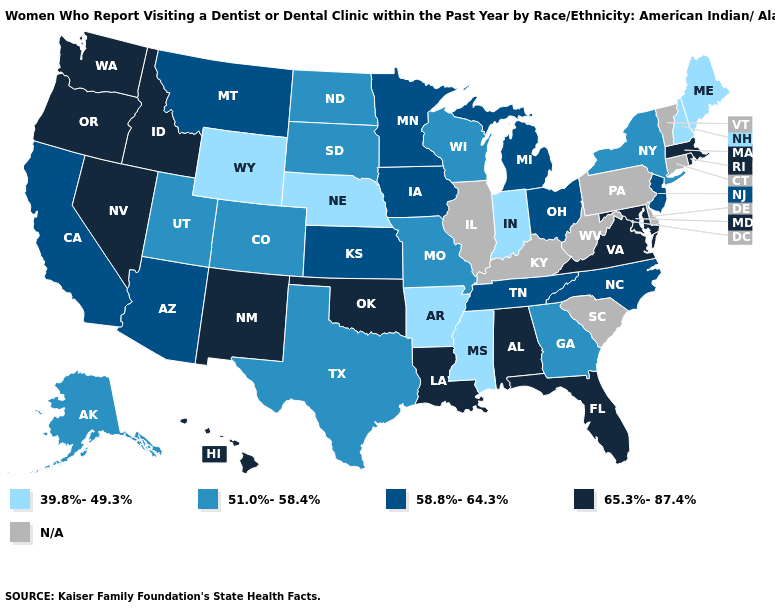Which states hav the highest value in the South?
Answer briefly. Alabama, Florida, Louisiana, Maryland, Oklahoma, Virginia. What is the lowest value in the Northeast?
Give a very brief answer. 39.8%-49.3%. Does Arkansas have the highest value in the South?
Quick response, please. No. What is the highest value in the USA?
Write a very short answer. 65.3%-87.4%. What is the value of Maryland?
Give a very brief answer. 65.3%-87.4%. Among the states that border Massachusetts , which have the lowest value?
Give a very brief answer. New Hampshire. Does Montana have the lowest value in the West?
Quick response, please. No. Which states have the lowest value in the West?
Keep it brief. Wyoming. Name the states that have a value in the range 51.0%-58.4%?
Answer briefly. Alaska, Colorado, Georgia, Missouri, New York, North Dakota, South Dakota, Texas, Utah, Wisconsin. Does the first symbol in the legend represent the smallest category?
Short answer required. Yes. Name the states that have a value in the range N/A?
Quick response, please. Connecticut, Delaware, Illinois, Kentucky, Pennsylvania, South Carolina, Vermont, West Virginia. Name the states that have a value in the range 58.8%-64.3%?
Quick response, please. Arizona, California, Iowa, Kansas, Michigan, Minnesota, Montana, New Jersey, North Carolina, Ohio, Tennessee. Is the legend a continuous bar?
Concise answer only. No. Does Mississippi have the lowest value in the USA?
Give a very brief answer. Yes. Name the states that have a value in the range 51.0%-58.4%?
Concise answer only. Alaska, Colorado, Georgia, Missouri, New York, North Dakota, South Dakota, Texas, Utah, Wisconsin. 